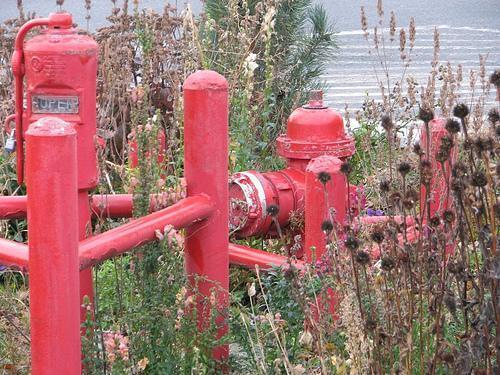How many fire hydrants are visible?
Give a very brief answer. 3. 